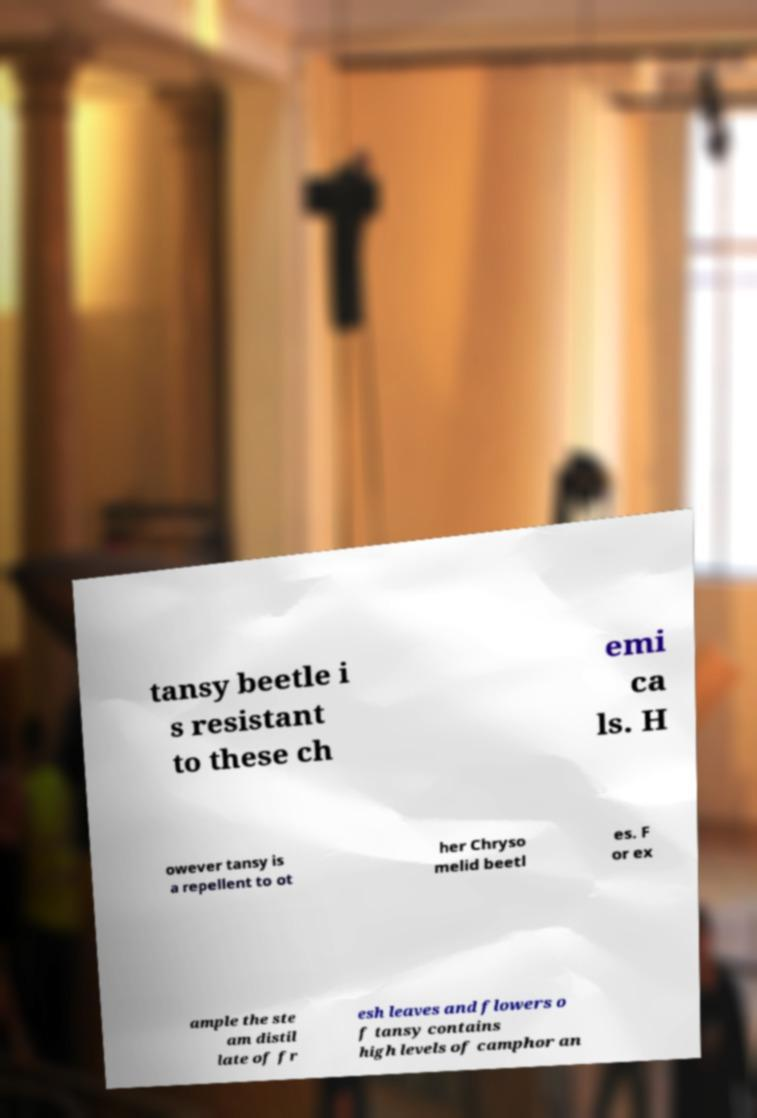Can you read and provide the text displayed in the image?This photo seems to have some interesting text. Can you extract and type it out for me? tansy beetle i s resistant to these ch emi ca ls. H owever tansy is a repellent to ot her Chryso melid beetl es. F or ex ample the ste am distil late of fr esh leaves and flowers o f tansy contains high levels of camphor an 